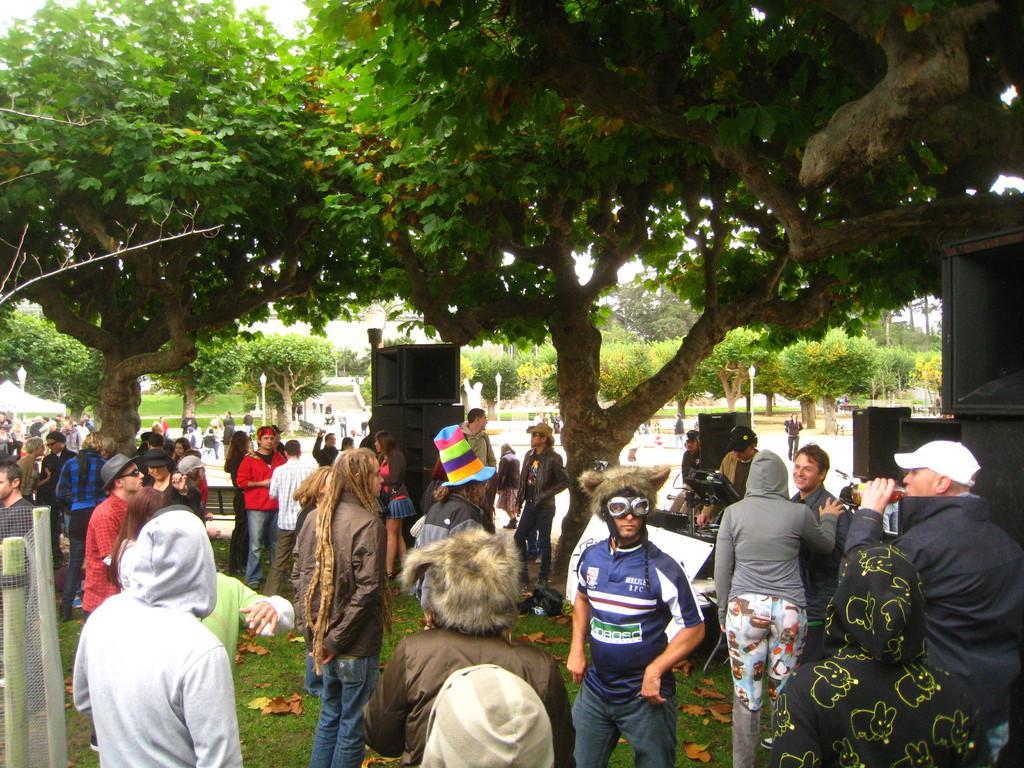How would you summarize this image in a sentence or two? We can see group of people and we can see grass,trees and speakers. In the background we can see trees and lights on poles. 